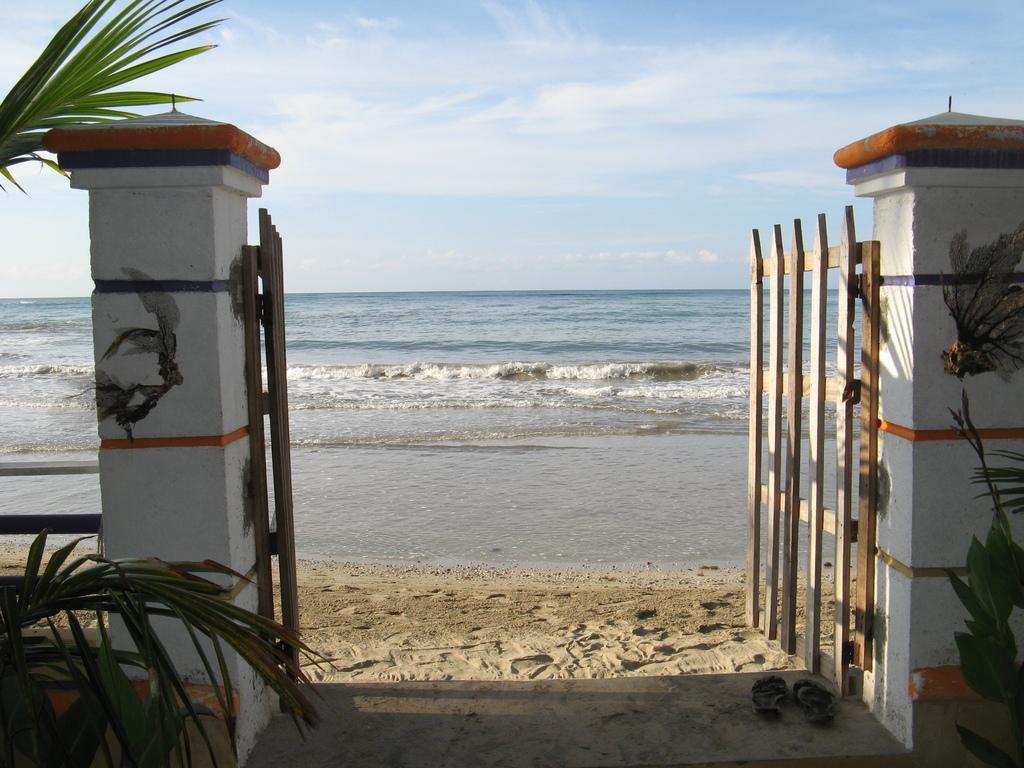Can you describe this image briefly? In the image there are two pillars with wooden gates. On the left and right side of the image there are plants. At the bottom of the image there is sand with footwear on it. Behind the gate there is sea. At the top of the image there is a sky. 